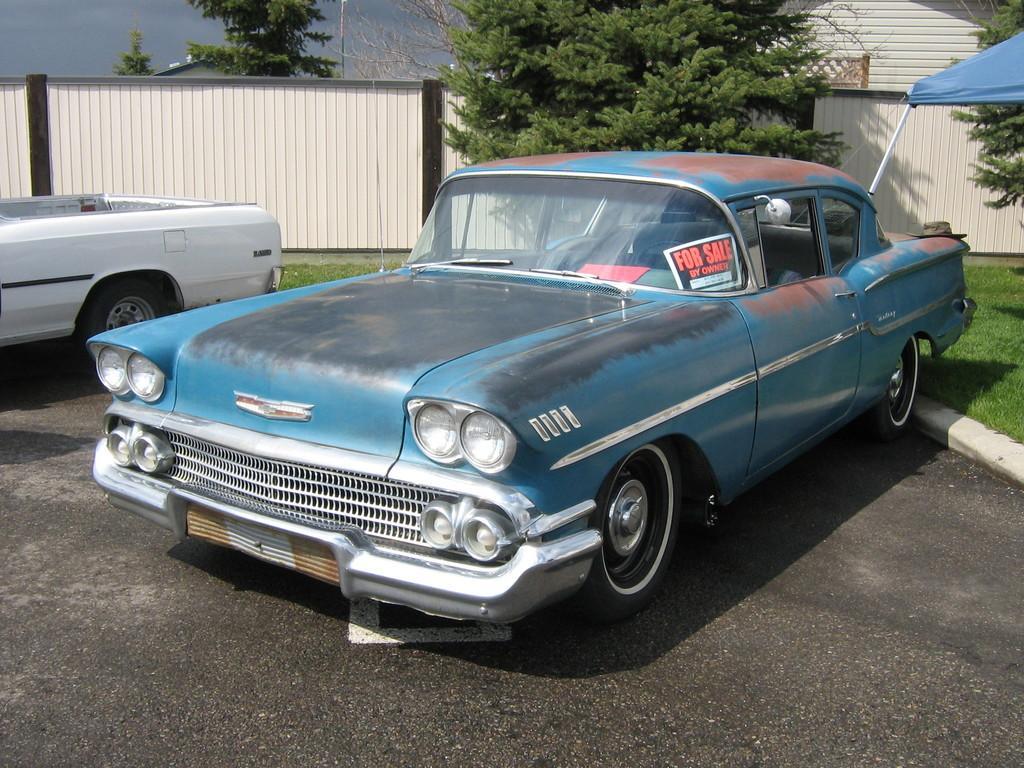Describe this image in one or two sentences. In this picture we can see vehicle on the road, grass, tent, wall, house, trees and roof. In the background of the image we can see the sky. 